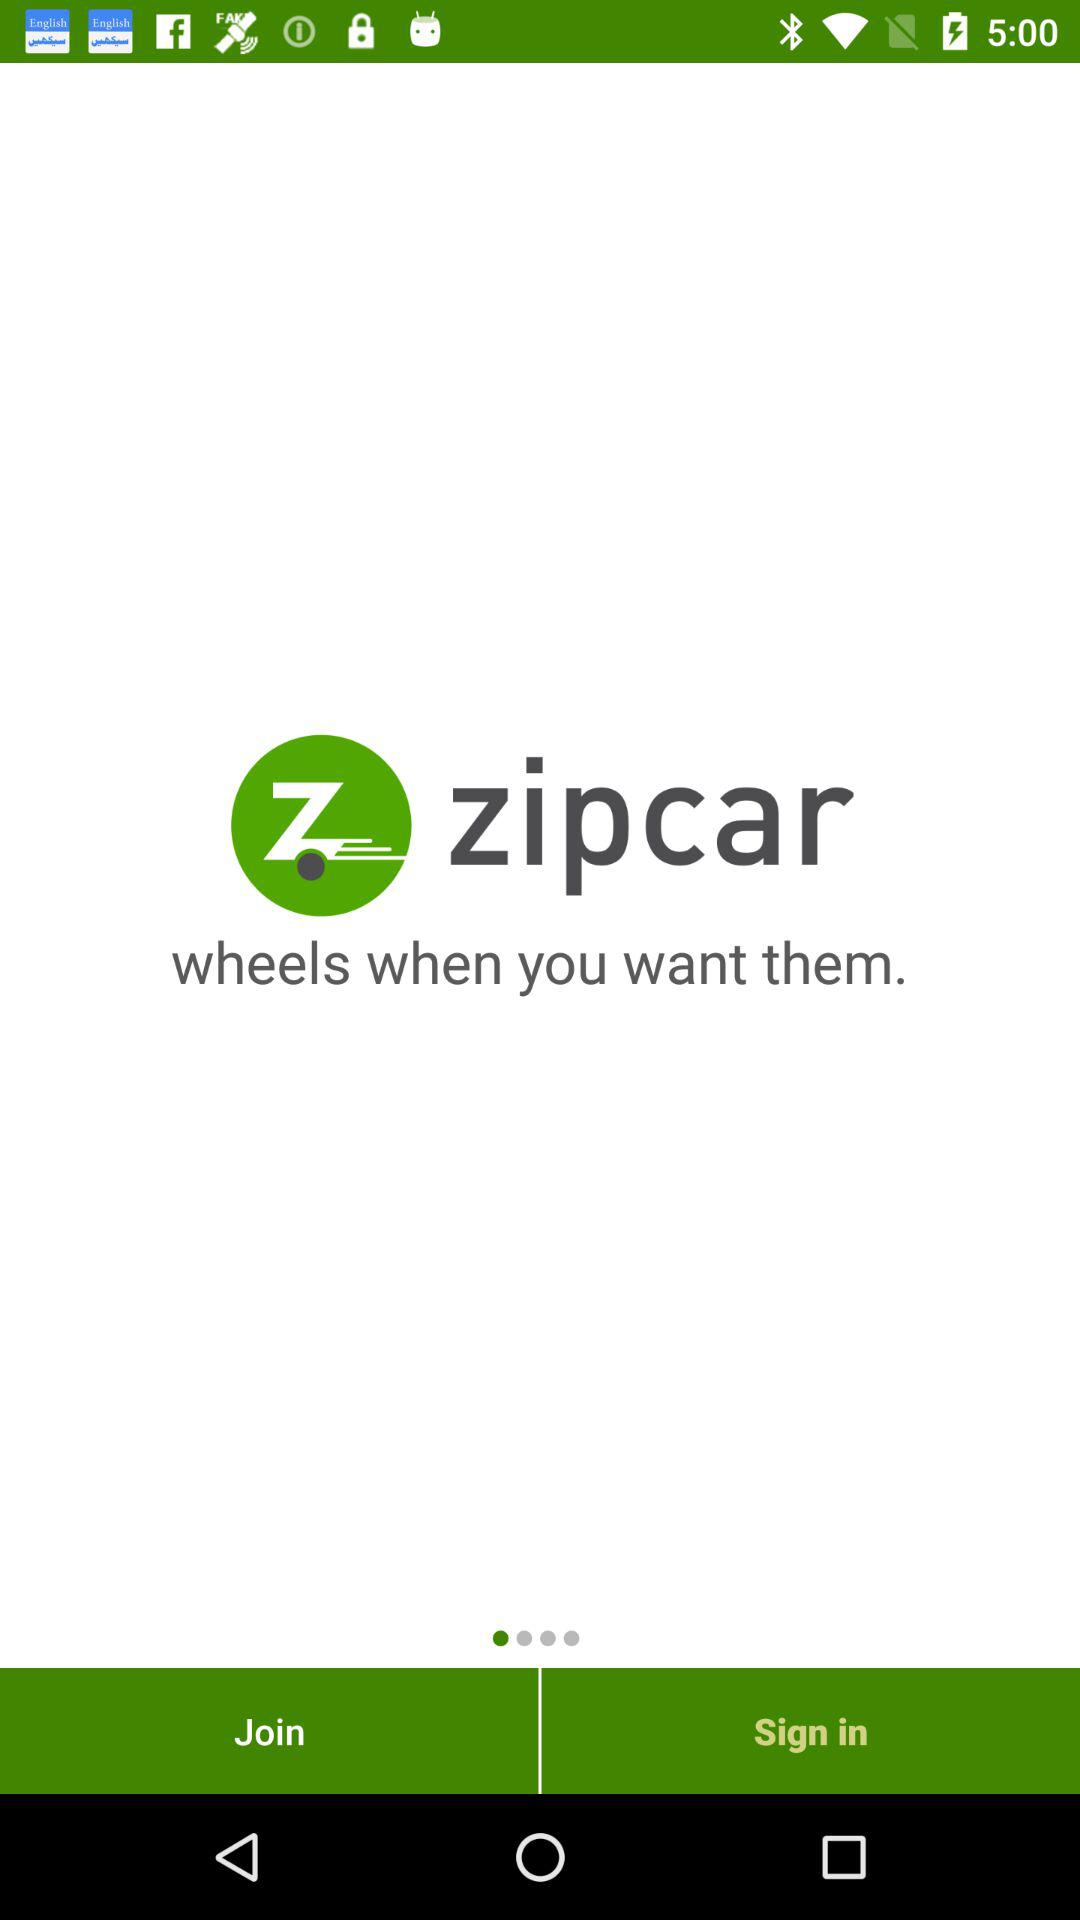What is the name of the application? The name of the application is "zipcar". 